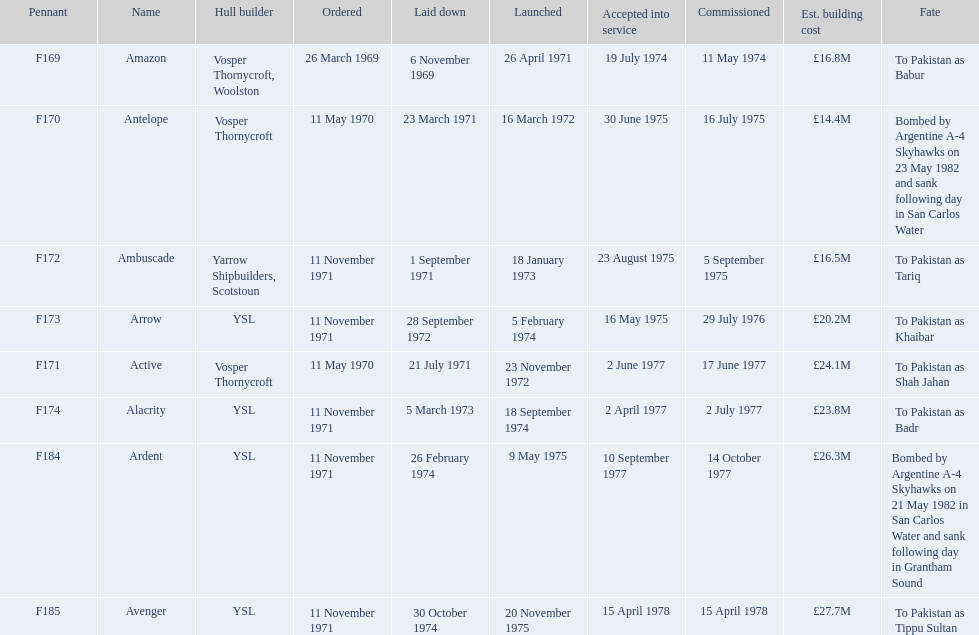How many ships were laid down in september? 2. 